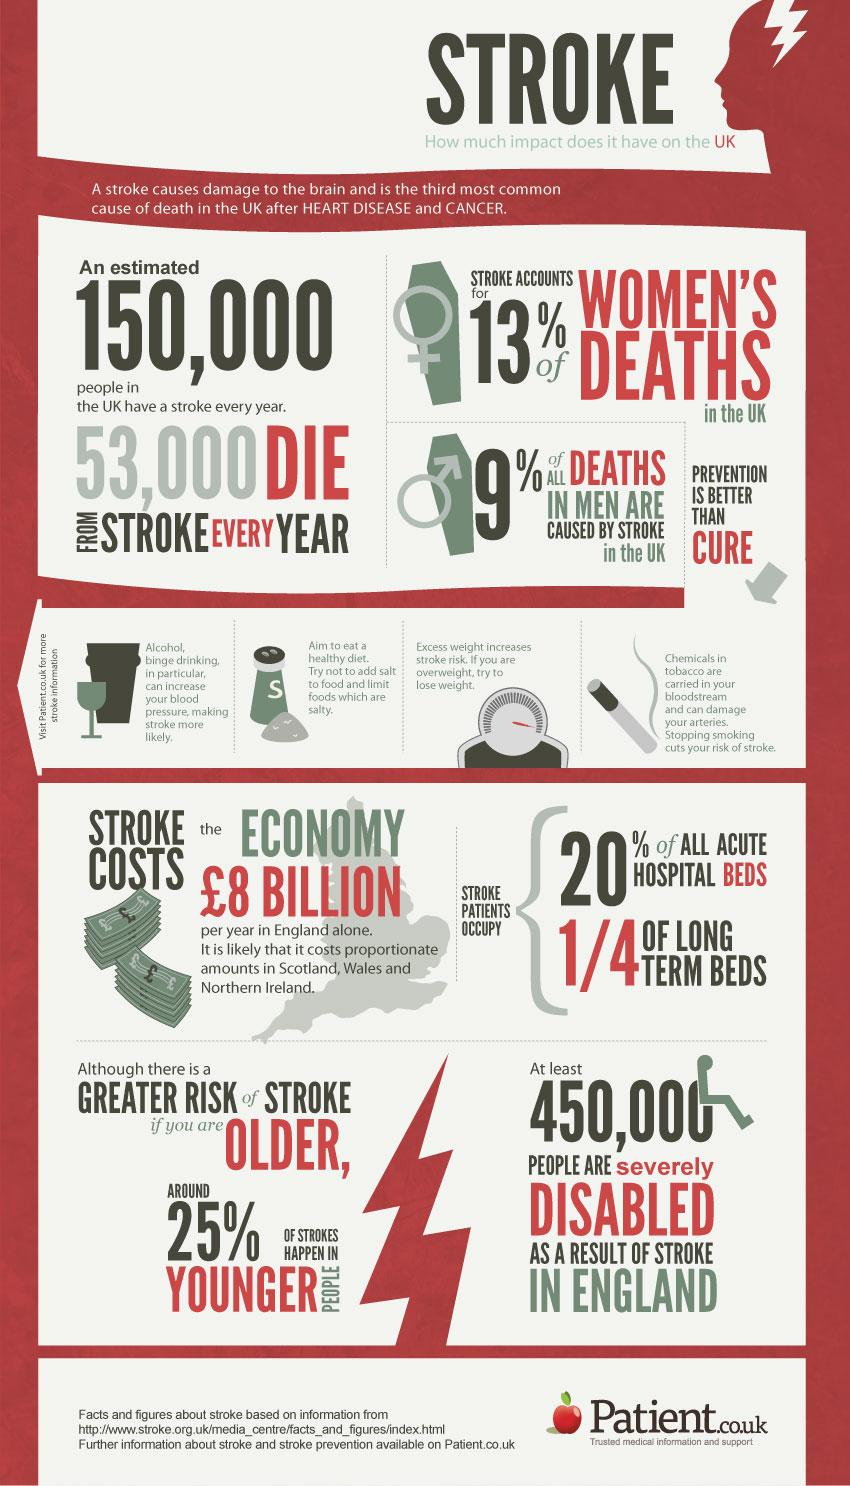Highlight a few significant elements in this photo. Approximately 970,000 people survive strokes annually. According to recent studies, it has been found that approximately 75% of all strokes occur in elderly individuals. According to statistics, cancer is the second most common cause of death in the United Kingdom. In the UK, heart disease is the most common cause of death. 